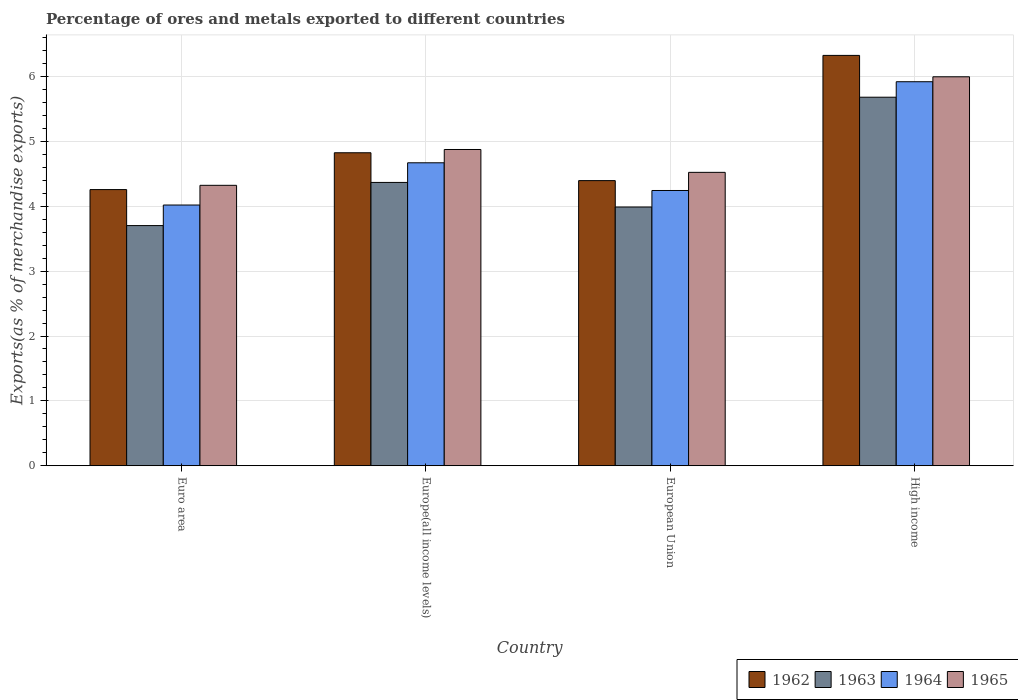Are the number of bars per tick equal to the number of legend labels?
Ensure brevity in your answer.  Yes. How many bars are there on the 4th tick from the left?
Give a very brief answer. 4. What is the label of the 1st group of bars from the left?
Make the answer very short. Euro area. What is the percentage of exports to different countries in 1962 in European Union?
Offer a very short reply. 4.4. Across all countries, what is the maximum percentage of exports to different countries in 1962?
Keep it short and to the point. 6.33. Across all countries, what is the minimum percentage of exports to different countries in 1965?
Keep it short and to the point. 4.32. What is the total percentage of exports to different countries in 1962 in the graph?
Your answer should be compact. 19.81. What is the difference between the percentage of exports to different countries in 1965 in Europe(all income levels) and that in European Union?
Offer a terse response. 0.35. What is the difference between the percentage of exports to different countries in 1962 in Euro area and the percentage of exports to different countries in 1963 in High income?
Provide a succinct answer. -1.42. What is the average percentage of exports to different countries in 1965 per country?
Keep it short and to the point. 4.93. What is the difference between the percentage of exports to different countries of/in 1963 and percentage of exports to different countries of/in 1962 in European Union?
Keep it short and to the point. -0.41. In how many countries, is the percentage of exports to different countries in 1964 greater than 2.6 %?
Your answer should be compact. 4. What is the ratio of the percentage of exports to different countries in 1962 in Euro area to that in Europe(all income levels)?
Provide a short and direct response. 0.88. Is the percentage of exports to different countries in 1965 in European Union less than that in High income?
Offer a very short reply. Yes. Is the difference between the percentage of exports to different countries in 1963 in Europe(all income levels) and European Union greater than the difference between the percentage of exports to different countries in 1962 in Europe(all income levels) and European Union?
Your answer should be compact. No. What is the difference between the highest and the second highest percentage of exports to different countries in 1962?
Provide a succinct answer. 0.43. What is the difference between the highest and the lowest percentage of exports to different countries in 1965?
Ensure brevity in your answer.  1.67. What does the 4th bar from the left in Euro area represents?
Provide a short and direct response. 1965. What does the 3rd bar from the right in Europe(all income levels) represents?
Your response must be concise. 1963. How many bars are there?
Your answer should be compact. 16. Are all the bars in the graph horizontal?
Keep it short and to the point. No. How many countries are there in the graph?
Offer a very short reply. 4. How many legend labels are there?
Offer a very short reply. 4. What is the title of the graph?
Your response must be concise. Percentage of ores and metals exported to different countries. Does "1998" appear as one of the legend labels in the graph?
Make the answer very short. No. What is the label or title of the Y-axis?
Give a very brief answer. Exports(as % of merchandise exports). What is the Exports(as % of merchandise exports) in 1962 in Euro area?
Offer a very short reply. 4.26. What is the Exports(as % of merchandise exports) of 1963 in Euro area?
Offer a very short reply. 3.7. What is the Exports(as % of merchandise exports) of 1964 in Euro area?
Ensure brevity in your answer.  4.02. What is the Exports(as % of merchandise exports) in 1965 in Euro area?
Your response must be concise. 4.32. What is the Exports(as % of merchandise exports) of 1962 in Europe(all income levels)?
Your response must be concise. 4.83. What is the Exports(as % of merchandise exports) of 1963 in Europe(all income levels)?
Provide a short and direct response. 4.37. What is the Exports(as % of merchandise exports) in 1964 in Europe(all income levels)?
Your answer should be very brief. 4.67. What is the Exports(as % of merchandise exports) of 1965 in Europe(all income levels)?
Keep it short and to the point. 4.88. What is the Exports(as % of merchandise exports) in 1962 in European Union?
Give a very brief answer. 4.4. What is the Exports(as % of merchandise exports) of 1963 in European Union?
Ensure brevity in your answer.  3.99. What is the Exports(as % of merchandise exports) of 1964 in European Union?
Your answer should be very brief. 4.24. What is the Exports(as % of merchandise exports) in 1965 in European Union?
Offer a terse response. 4.52. What is the Exports(as % of merchandise exports) in 1962 in High income?
Your response must be concise. 6.33. What is the Exports(as % of merchandise exports) in 1963 in High income?
Your answer should be very brief. 5.68. What is the Exports(as % of merchandise exports) of 1964 in High income?
Keep it short and to the point. 5.92. What is the Exports(as % of merchandise exports) in 1965 in High income?
Your response must be concise. 6. Across all countries, what is the maximum Exports(as % of merchandise exports) of 1962?
Your answer should be very brief. 6.33. Across all countries, what is the maximum Exports(as % of merchandise exports) in 1963?
Ensure brevity in your answer.  5.68. Across all countries, what is the maximum Exports(as % of merchandise exports) in 1964?
Offer a terse response. 5.92. Across all countries, what is the maximum Exports(as % of merchandise exports) of 1965?
Keep it short and to the point. 6. Across all countries, what is the minimum Exports(as % of merchandise exports) in 1962?
Provide a short and direct response. 4.26. Across all countries, what is the minimum Exports(as % of merchandise exports) of 1963?
Offer a terse response. 3.7. Across all countries, what is the minimum Exports(as % of merchandise exports) of 1964?
Your response must be concise. 4.02. Across all countries, what is the minimum Exports(as % of merchandise exports) in 1965?
Offer a terse response. 4.32. What is the total Exports(as % of merchandise exports) in 1962 in the graph?
Keep it short and to the point. 19.81. What is the total Exports(as % of merchandise exports) of 1963 in the graph?
Your answer should be very brief. 17.74. What is the total Exports(as % of merchandise exports) of 1964 in the graph?
Make the answer very short. 18.86. What is the total Exports(as % of merchandise exports) of 1965 in the graph?
Your answer should be compact. 19.72. What is the difference between the Exports(as % of merchandise exports) in 1962 in Euro area and that in Europe(all income levels)?
Your answer should be very brief. -0.57. What is the difference between the Exports(as % of merchandise exports) in 1963 in Euro area and that in Europe(all income levels)?
Offer a terse response. -0.67. What is the difference between the Exports(as % of merchandise exports) of 1964 in Euro area and that in Europe(all income levels)?
Offer a terse response. -0.65. What is the difference between the Exports(as % of merchandise exports) in 1965 in Euro area and that in Europe(all income levels)?
Your answer should be compact. -0.55. What is the difference between the Exports(as % of merchandise exports) of 1962 in Euro area and that in European Union?
Give a very brief answer. -0.14. What is the difference between the Exports(as % of merchandise exports) in 1963 in Euro area and that in European Union?
Keep it short and to the point. -0.29. What is the difference between the Exports(as % of merchandise exports) of 1964 in Euro area and that in European Union?
Provide a succinct answer. -0.22. What is the difference between the Exports(as % of merchandise exports) of 1965 in Euro area and that in European Union?
Make the answer very short. -0.2. What is the difference between the Exports(as % of merchandise exports) in 1962 in Euro area and that in High income?
Your answer should be compact. -2.07. What is the difference between the Exports(as % of merchandise exports) of 1963 in Euro area and that in High income?
Your response must be concise. -1.98. What is the difference between the Exports(as % of merchandise exports) in 1964 in Euro area and that in High income?
Offer a very short reply. -1.9. What is the difference between the Exports(as % of merchandise exports) of 1965 in Euro area and that in High income?
Provide a succinct answer. -1.67. What is the difference between the Exports(as % of merchandise exports) in 1962 in Europe(all income levels) and that in European Union?
Offer a very short reply. 0.43. What is the difference between the Exports(as % of merchandise exports) of 1963 in Europe(all income levels) and that in European Union?
Your answer should be very brief. 0.38. What is the difference between the Exports(as % of merchandise exports) of 1964 in Europe(all income levels) and that in European Union?
Ensure brevity in your answer.  0.43. What is the difference between the Exports(as % of merchandise exports) in 1965 in Europe(all income levels) and that in European Union?
Provide a succinct answer. 0.35. What is the difference between the Exports(as % of merchandise exports) in 1962 in Europe(all income levels) and that in High income?
Your response must be concise. -1.5. What is the difference between the Exports(as % of merchandise exports) of 1963 in Europe(all income levels) and that in High income?
Offer a terse response. -1.31. What is the difference between the Exports(as % of merchandise exports) in 1964 in Europe(all income levels) and that in High income?
Offer a very short reply. -1.25. What is the difference between the Exports(as % of merchandise exports) in 1965 in Europe(all income levels) and that in High income?
Give a very brief answer. -1.12. What is the difference between the Exports(as % of merchandise exports) in 1962 in European Union and that in High income?
Offer a very short reply. -1.93. What is the difference between the Exports(as % of merchandise exports) in 1963 in European Union and that in High income?
Make the answer very short. -1.69. What is the difference between the Exports(as % of merchandise exports) of 1964 in European Union and that in High income?
Ensure brevity in your answer.  -1.68. What is the difference between the Exports(as % of merchandise exports) of 1965 in European Union and that in High income?
Provide a succinct answer. -1.47. What is the difference between the Exports(as % of merchandise exports) of 1962 in Euro area and the Exports(as % of merchandise exports) of 1963 in Europe(all income levels)?
Offer a terse response. -0.11. What is the difference between the Exports(as % of merchandise exports) in 1962 in Euro area and the Exports(as % of merchandise exports) in 1964 in Europe(all income levels)?
Your answer should be very brief. -0.41. What is the difference between the Exports(as % of merchandise exports) of 1962 in Euro area and the Exports(as % of merchandise exports) of 1965 in Europe(all income levels)?
Offer a terse response. -0.62. What is the difference between the Exports(as % of merchandise exports) of 1963 in Euro area and the Exports(as % of merchandise exports) of 1964 in Europe(all income levels)?
Your answer should be very brief. -0.97. What is the difference between the Exports(as % of merchandise exports) in 1963 in Euro area and the Exports(as % of merchandise exports) in 1965 in Europe(all income levels)?
Make the answer very short. -1.17. What is the difference between the Exports(as % of merchandise exports) of 1964 in Euro area and the Exports(as % of merchandise exports) of 1965 in Europe(all income levels)?
Provide a short and direct response. -0.86. What is the difference between the Exports(as % of merchandise exports) of 1962 in Euro area and the Exports(as % of merchandise exports) of 1963 in European Union?
Offer a terse response. 0.27. What is the difference between the Exports(as % of merchandise exports) of 1962 in Euro area and the Exports(as % of merchandise exports) of 1964 in European Union?
Ensure brevity in your answer.  0.01. What is the difference between the Exports(as % of merchandise exports) of 1962 in Euro area and the Exports(as % of merchandise exports) of 1965 in European Union?
Provide a succinct answer. -0.27. What is the difference between the Exports(as % of merchandise exports) in 1963 in Euro area and the Exports(as % of merchandise exports) in 1964 in European Union?
Offer a very short reply. -0.54. What is the difference between the Exports(as % of merchandise exports) in 1963 in Euro area and the Exports(as % of merchandise exports) in 1965 in European Union?
Offer a very short reply. -0.82. What is the difference between the Exports(as % of merchandise exports) of 1964 in Euro area and the Exports(as % of merchandise exports) of 1965 in European Union?
Your answer should be very brief. -0.5. What is the difference between the Exports(as % of merchandise exports) in 1962 in Euro area and the Exports(as % of merchandise exports) in 1963 in High income?
Give a very brief answer. -1.42. What is the difference between the Exports(as % of merchandise exports) of 1962 in Euro area and the Exports(as % of merchandise exports) of 1964 in High income?
Your response must be concise. -1.66. What is the difference between the Exports(as % of merchandise exports) of 1962 in Euro area and the Exports(as % of merchandise exports) of 1965 in High income?
Make the answer very short. -1.74. What is the difference between the Exports(as % of merchandise exports) in 1963 in Euro area and the Exports(as % of merchandise exports) in 1964 in High income?
Provide a short and direct response. -2.22. What is the difference between the Exports(as % of merchandise exports) of 1963 in Euro area and the Exports(as % of merchandise exports) of 1965 in High income?
Ensure brevity in your answer.  -2.29. What is the difference between the Exports(as % of merchandise exports) in 1964 in Euro area and the Exports(as % of merchandise exports) in 1965 in High income?
Provide a succinct answer. -1.98. What is the difference between the Exports(as % of merchandise exports) in 1962 in Europe(all income levels) and the Exports(as % of merchandise exports) in 1963 in European Union?
Your answer should be very brief. 0.84. What is the difference between the Exports(as % of merchandise exports) in 1962 in Europe(all income levels) and the Exports(as % of merchandise exports) in 1964 in European Union?
Provide a short and direct response. 0.58. What is the difference between the Exports(as % of merchandise exports) in 1962 in Europe(all income levels) and the Exports(as % of merchandise exports) in 1965 in European Union?
Give a very brief answer. 0.3. What is the difference between the Exports(as % of merchandise exports) in 1963 in Europe(all income levels) and the Exports(as % of merchandise exports) in 1964 in European Union?
Your answer should be compact. 0.12. What is the difference between the Exports(as % of merchandise exports) in 1963 in Europe(all income levels) and the Exports(as % of merchandise exports) in 1965 in European Union?
Offer a very short reply. -0.16. What is the difference between the Exports(as % of merchandise exports) in 1964 in Europe(all income levels) and the Exports(as % of merchandise exports) in 1965 in European Union?
Make the answer very short. 0.15. What is the difference between the Exports(as % of merchandise exports) in 1962 in Europe(all income levels) and the Exports(as % of merchandise exports) in 1963 in High income?
Ensure brevity in your answer.  -0.86. What is the difference between the Exports(as % of merchandise exports) of 1962 in Europe(all income levels) and the Exports(as % of merchandise exports) of 1964 in High income?
Provide a short and direct response. -1.1. What is the difference between the Exports(as % of merchandise exports) of 1962 in Europe(all income levels) and the Exports(as % of merchandise exports) of 1965 in High income?
Give a very brief answer. -1.17. What is the difference between the Exports(as % of merchandise exports) in 1963 in Europe(all income levels) and the Exports(as % of merchandise exports) in 1964 in High income?
Keep it short and to the point. -1.55. What is the difference between the Exports(as % of merchandise exports) of 1963 in Europe(all income levels) and the Exports(as % of merchandise exports) of 1965 in High income?
Provide a succinct answer. -1.63. What is the difference between the Exports(as % of merchandise exports) in 1964 in Europe(all income levels) and the Exports(as % of merchandise exports) in 1965 in High income?
Offer a very short reply. -1.33. What is the difference between the Exports(as % of merchandise exports) in 1962 in European Union and the Exports(as % of merchandise exports) in 1963 in High income?
Make the answer very short. -1.29. What is the difference between the Exports(as % of merchandise exports) of 1962 in European Union and the Exports(as % of merchandise exports) of 1964 in High income?
Provide a succinct answer. -1.53. What is the difference between the Exports(as % of merchandise exports) of 1962 in European Union and the Exports(as % of merchandise exports) of 1965 in High income?
Offer a very short reply. -1.6. What is the difference between the Exports(as % of merchandise exports) in 1963 in European Union and the Exports(as % of merchandise exports) in 1964 in High income?
Provide a short and direct response. -1.93. What is the difference between the Exports(as % of merchandise exports) of 1963 in European Union and the Exports(as % of merchandise exports) of 1965 in High income?
Your answer should be very brief. -2.01. What is the difference between the Exports(as % of merchandise exports) of 1964 in European Union and the Exports(as % of merchandise exports) of 1965 in High income?
Keep it short and to the point. -1.75. What is the average Exports(as % of merchandise exports) of 1962 per country?
Make the answer very short. 4.95. What is the average Exports(as % of merchandise exports) of 1963 per country?
Give a very brief answer. 4.44. What is the average Exports(as % of merchandise exports) in 1964 per country?
Provide a short and direct response. 4.71. What is the average Exports(as % of merchandise exports) in 1965 per country?
Ensure brevity in your answer.  4.93. What is the difference between the Exports(as % of merchandise exports) of 1962 and Exports(as % of merchandise exports) of 1963 in Euro area?
Provide a short and direct response. 0.56. What is the difference between the Exports(as % of merchandise exports) in 1962 and Exports(as % of merchandise exports) in 1964 in Euro area?
Make the answer very short. 0.24. What is the difference between the Exports(as % of merchandise exports) of 1962 and Exports(as % of merchandise exports) of 1965 in Euro area?
Keep it short and to the point. -0.07. What is the difference between the Exports(as % of merchandise exports) in 1963 and Exports(as % of merchandise exports) in 1964 in Euro area?
Make the answer very short. -0.32. What is the difference between the Exports(as % of merchandise exports) of 1963 and Exports(as % of merchandise exports) of 1965 in Euro area?
Your answer should be very brief. -0.62. What is the difference between the Exports(as % of merchandise exports) in 1964 and Exports(as % of merchandise exports) in 1965 in Euro area?
Ensure brevity in your answer.  -0.3. What is the difference between the Exports(as % of merchandise exports) in 1962 and Exports(as % of merchandise exports) in 1963 in Europe(all income levels)?
Give a very brief answer. 0.46. What is the difference between the Exports(as % of merchandise exports) in 1962 and Exports(as % of merchandise exports) in 1964 in Europe(all income levels)?
Offer a terse response. 0.15. What is the difference between the Exports(as % of merchandise exports) in 1962 and Exports(as % of merchandise exports) in 1965 in Europe(all income levels)?
Your response must be concise. -0.05. What is the difference between the Exports(as % of merchandise exports) of 1963 and Exports(as % of merchandise exports) of 1964 in Europe(all income levels)?
Your answer should be compact. -0.3. What is the difference between the Exports(as % of merchandise exports) of 1963 and Exports(as % of merchandise exports) of 1965 in Europe(all income levels)?
Make the answer very short. -0.51. What is the difference between the Exports(as % of merchandise exports) of 1964 and Exports(as % of merchandise exports) of 1965 in Europe(all income levels)?
Provide a succinct answer. -0.2. What is the difference between the Exports(as % of merchandise exports) in 1962 and Exports(as % of merchandise exports) in 1963 in European Union?
Offer a very short reply. 0.41. What is the difference between the Exports(as % of merchandise exports) of 1962 and Exports(as % of merchandise exports) of 1964 in European Union?
Your answer should be compact. 0.15. What is the difference between the Exports(as % of merchandise exports) in 1962 and Exports(as % of merchandise exports) in 1965 in European Union?
Your answer should be compact. -0.13. What is the difference between the Exports(as % of merchandise exports) in 1963 and Exports(as % of merchandise exports) in 1964 in European Union?
Offer a terse response. -0.25. What is the difference between the Exports(as % of merchandise exports) in 1963 and Exports(as % of merchandise exports) in 1965 in European Union?
Make the answer very short. -0.53. What is the difference between the Exports(as % of merchandise exports) in 1964 and Exports(as % of merchandise exports) in 1965 in European Union?
Ensure brevity in your answer.  -0.28. What is the difference between the Exports(as % of merchandise exports) in 1962 and Exports(as % of merchandise exports) in 1963 in High income?
Keep it short and to the point. 0.64. What is the difference between the Exports(as % of merchandise exports) in 1962 and Exports(as % of merchandise exports) in 1964 in High income?
Your answer should be compact. 0.41. What is the difference between the Exports(as % of merchandise exports) of 1962 and Exports(as % of merchandise exports) of 1965 in High income?
Make the answer very short. 0.33. What is the difference between the Exports(as % of merchandise exports) in 1963 and Exports(as % of merchandise exports) in 1964 in High income?
Make the answer very short. -0.24. What is the difference between the Exports(as % of merchandise exports) of 1963 and Exports(as % of merchandise exports) of 1965 in High income?
Offer a very short reply. -0.31. What is the difference between the Exports(as % of merchandise exports) of 1964 and Exports(as % of merchandise exports) of 1965 in High income?
Provide a succinct answer. -0.08. What is the ratio of the Exports(as % of merchandise exports) in 1962 in Euro area to that in Europe(all income levels)?
Provide a short and direct response. 0.88. What is the ratio of the Exports(as % of merchandise exports) of 1963 in Euro area to that in Europe(all income levels)?
Keep it short and to the point. 0.85. What is the ratio of the Exports(as % of merchandise exports) of 1964 in Euro area to that in Europe(all income levels)?
Keep it short and to the point. 0.86. What is the ratio of the Exports(as % of merchandise exports) in 1965 in Euro area to that in Europe(all income levels)?
Keep it short and to the point. 0.89. What is the ratio of the Exports(as % of merchandise exports) in 1962 in Euro area to that in European Union?
Your answer should be compact. 0.97. What is the ratio of the Exports(as % of merchandise exports) in 1963 in Euro area to that in European Union?
Give a very brief answer. 0.93. What is the ratio of the Exports(as % of merchandise exports) of 1964 in Euro area to that in European Union?
Offer a terse response. 0.95. What is the ratio of the Exports(as % of merchandise exports) in 1965 in Euro area to that in European Union?
Keep it short and to the point. 0.96. What is the ratio of the Exports(as % of merchandise exports) in 1962 in Euro area to that in High income?
Ensure brevity in your answer.  0.67. What is the ratio of the Exports(as % of merchandise exports) of 1963 in Euro area to that in High income?
Offer a terse response. 0.65. What is the ratio of the Exports(as % of merchandise exports) of 1964 in Euro area to that in High income?
Make the answer very short. 0.68. What is the ratio of the Exports(as % of merchandise exports) of 1965 in Euro area to that in High income?
Provide a short and direct response. 0.72. What is the ratio of the Exports(as % of merchandise exports) in 1962 in Europe(all income levels) to that in European Union?
Your response must be concise. 1.1. What is the ratio of the Exports(as % of merchandise exports) in 1963 in Europe(all income levels) to that in European Union?
Keep it short and to the point. 1.09. What is the ratio of the Exports(as % of merchandise exports) in 1964 in Europe(all income levels) to that in European Union?
Ensure brevity in your answer.  1.1. What is the ratio of the Exports(as % of merchandise exports) in 1965 in Europe(all income levels) to that in European Union?
Your answer should be compact. 1.08. What is the ratio of the Exports(as % of merchandise exports) of 1962 in Europe(all income levels) to that in High income?
Offer a terse response. 0.76. What is the ratio of the Exports(as % of merchandise exports) in 1963 in Europe(all income levels) to that in High income?
Provide a succinct answer. 0.77. What is the ratio of the Exports(as % of merchandise exports) in 1964 in Europe(all income levels) to that in High income?
Keep it short and to the point. 0.79. What is the ratio of the Exports(as % of merchandise exports) in 1965 in Europe(all income levels) to that in High income?
Offer a very short reply. 0.81. What is the ratio of the Exports(as % of merchandise exports) of 1962 in European Union to that in High income?
Provide a succinct answer. 0.69. What is the ratio of the Exports(as % of merchandise exports) in 1963 in European Union to that in High income?
Provide a short and direct response. 0.7. What is the ratio of the Exports(as % of merchandise exports) in 1964 in European Union to that in High income?
Your answer should be compact. 0.72. What is the ratio of the Exports(as % of merchandise exports) in 1965 in European Union to that in High income?
Provide a short and direct response. 0.75. What is the difference between the highest and the second highest Exports(as % of merchandise exports) of 1962?
Your answer should be very brief. 1.5. What is the difference between the highest and the second highest Exports(as % of merchandise exports) in 1963?
Your response must be concise. 1.31. What is the difference between the highest and the second highest Exports(as % of merchandise exports) in 1965?
Ensure brevity in your answer.  1.12. What is the difference between the highest and the lowest Exports(as % of merchandise exports) of 1962?
Ensure brevity in your answer.  2.07. What is the difference between the highest and the lowest Exports(as % of merchandise exports) in 1963?
Provide a short and direct response. 1.98. What is the difference between the highest and the lowest Exports(as % of merchandise exports) of 1964?
Provide a short and direct response. 1.9. What is the difference between the highest and the lowest Exports(as % of merchandise exports) in 1965?
Your answer should be compact. 1.67. 